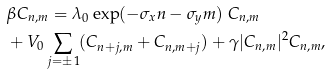Convert formula to latex. <formula><loc_0><loc_0><loc_500><loc_500>& \beta C _ { n , m } = \lambda _ { 0 } \exp ( - \sigma _ { x } n - \sigma _ { y } m ) \ C _ { n , m } \\ & + V _ { 0 } \sum _ { j = \pm 1 } ( C _ { n + j , m } + C _ { n , m + j } ) + \gamma | C _ { n , m } | ^ { 2 } C _ { n , m } ,</formula> 